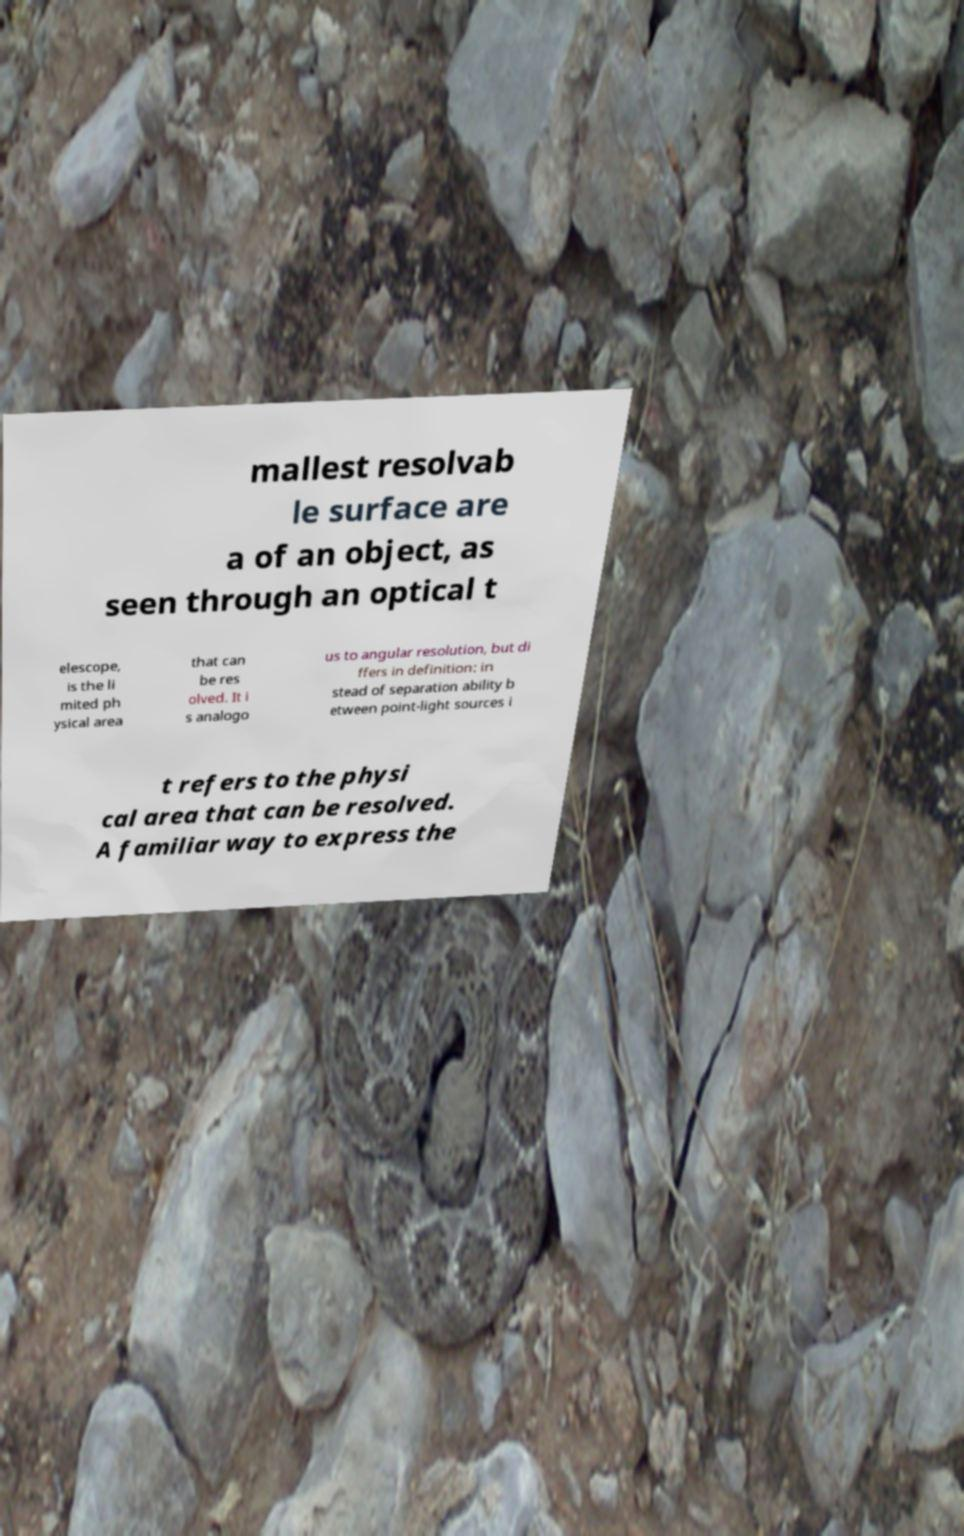Can you accurately transcribe the text from the provided image for me? mallest resolvab le surface are a of an object, as seen through an optical t elescope, is the li mited ph ysical area that can be res olved. It i s analogo us to angular resolution, but di ffers in definition: in stead of separation ability b etween point-light sources i t refers to the physi cal area that can be resolved. A familiar way to express the 